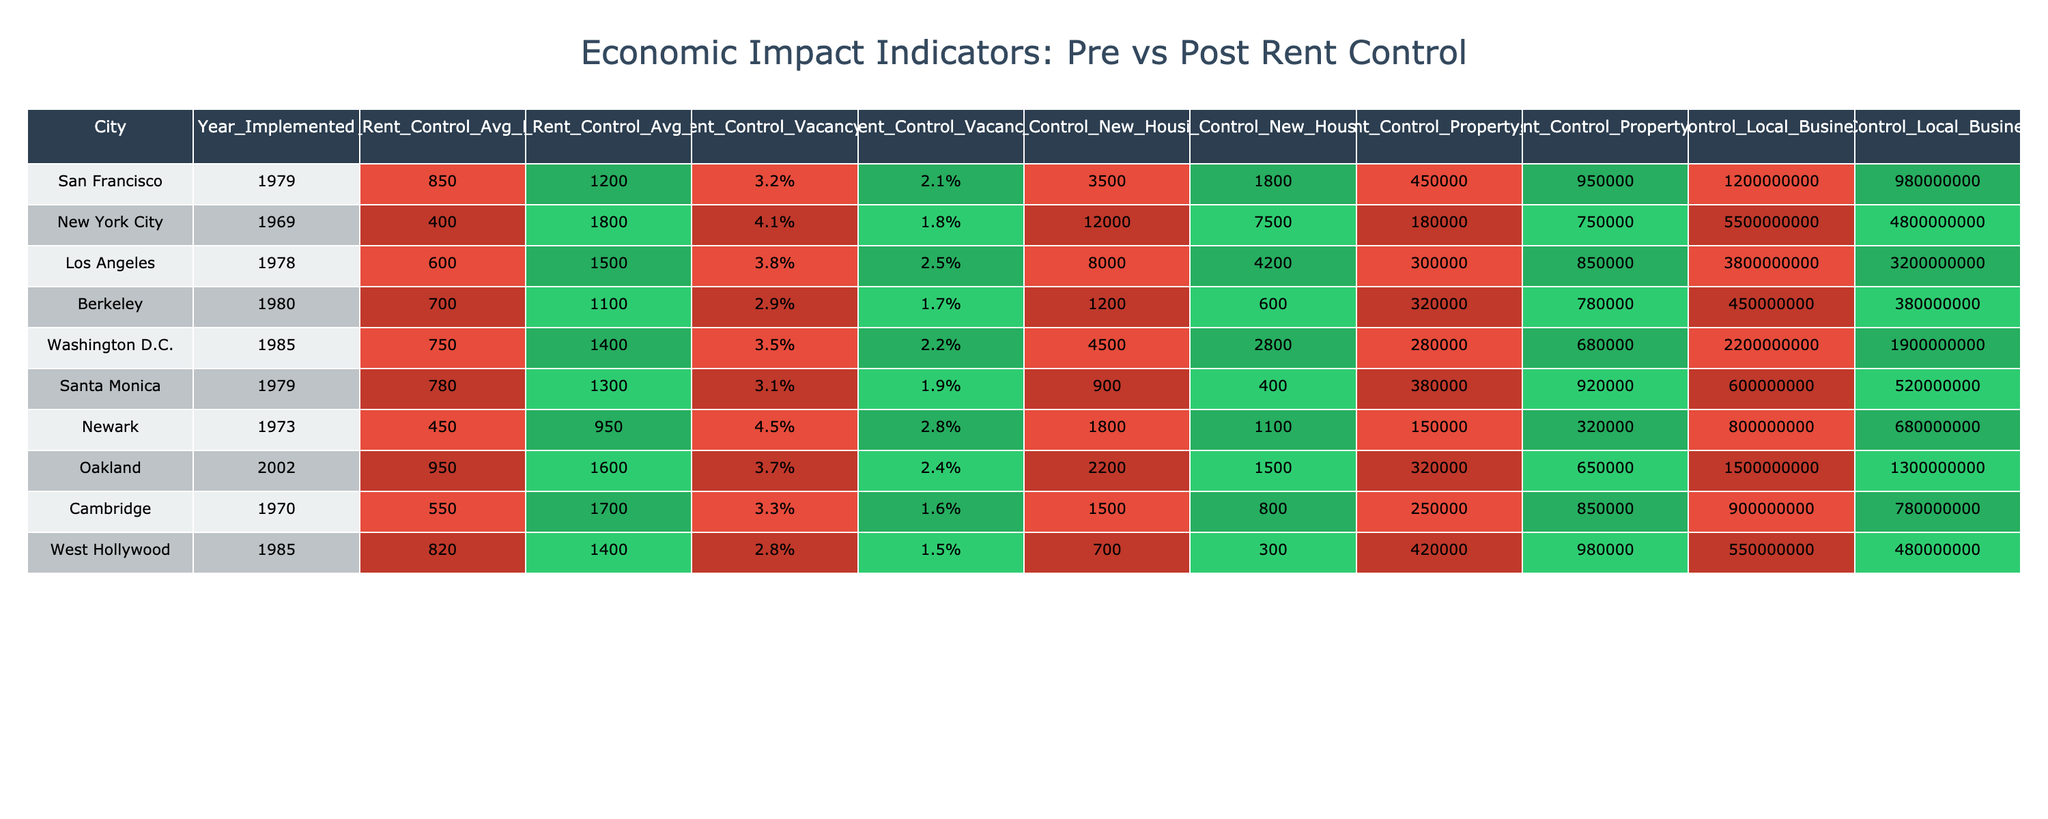What was the average rent in San Francisco before implementing rent control? The table shows that the average rent in San Francisco before implementing rent control was $850.
Answer: $850 What is the difference in average rent before and after rent control in New York City? In New York City, the average rent before rent control was $400 and after it was $1,800. The difference is $1,800 - $400 = $1,400.
Answer: $1,400 Which city experienced the largest drop in new housing starts after implementing rent control? Looking at the new housing starts, Los Angeles dropped from 8,000 to 4,200, a change of 3,800. San Francisco also dropped, from 3,500 to 1,800, which is a change of 1,700. The largest drop was in Los Angeles.
Answer: Los Angeles Did the vacancy rate in Washington D.C. increase or decrease after implementing rent control? The vacancy rate in Washington D.C. was 3.5% before and 2.2% after implementing rent control, indicating a decrease.
Answer: Decrease What was the total change in local business revenue for all the cities listed after rent control was implemented? To calculate, sum the post-rent control revenues and subtract the sum of pre-rent control revenues: (980000000 + 4800000000 + 3200000000 + 380000000 + 1900000000 + 520000000 + 680000000 + 1300000000 + 780000000) - (1200000000 + 5500000000 + 3800000000 + 450000000 + 2200000000 + 600000000 + 800000000 + 1500000000 + 900000000) = -1500000000.
Answer: -$1,500,000,000 What city had the highest property value increase after rent control was implemented? Comparing property values, San Francisco increased from $450,000 to $950,000 (an increase of $500,000). Cambridge increased from $250,000 to $850,000 (an increase of $600,000). New York City also had a significant increase from $180,000 to $750,000 (an increase of $570,000). Cambridge had the highest increase.
Answer: Cambridge Which city had a vacancy rate lower than 2% after implementing rent control? The only cities with a vacancy rate below 2% after implementing rent control are New York City (1.8%), Berkeley (1.7%), and West Hollywood (1.5%).
Answer: New York City, Berkeley, West Hollywood What is the average decrease in average rent across all cities after implementing rent control? Calculate the average decrease in average rent: ((1200 - 850) + (1800 - 400) + (1500 - 600) + (1100 - 700) + (1400 - 750) + (1300 - 780) + (950 - 450) + (1600 - 950) + (1700 - 550)) / 9 = $547.22.
Answer: $547.22 Is it true that all cities had a decrease in local business revenue after implementing rent control? Looking at the local business revenue, San Francisco, New York City, Los Angeles, Washington D.C., and Santa Monica all experienced declines, while Newark, Oakland, Cambridge, and West Hollywood also saw declines. Thus, it's true that all cities had a decrease in local business revenue.
Answer: True 